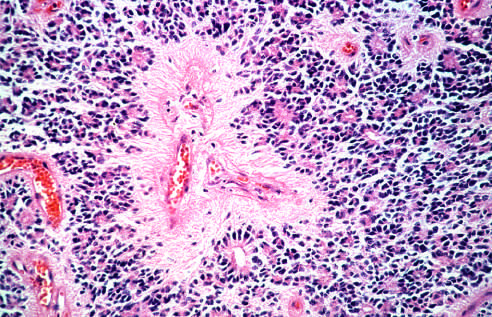do tumor cells have round nuclei, often with a clear cytoplasmic halo in oligodendroglioma?
Answer the question using a single word or phrase. Yes 